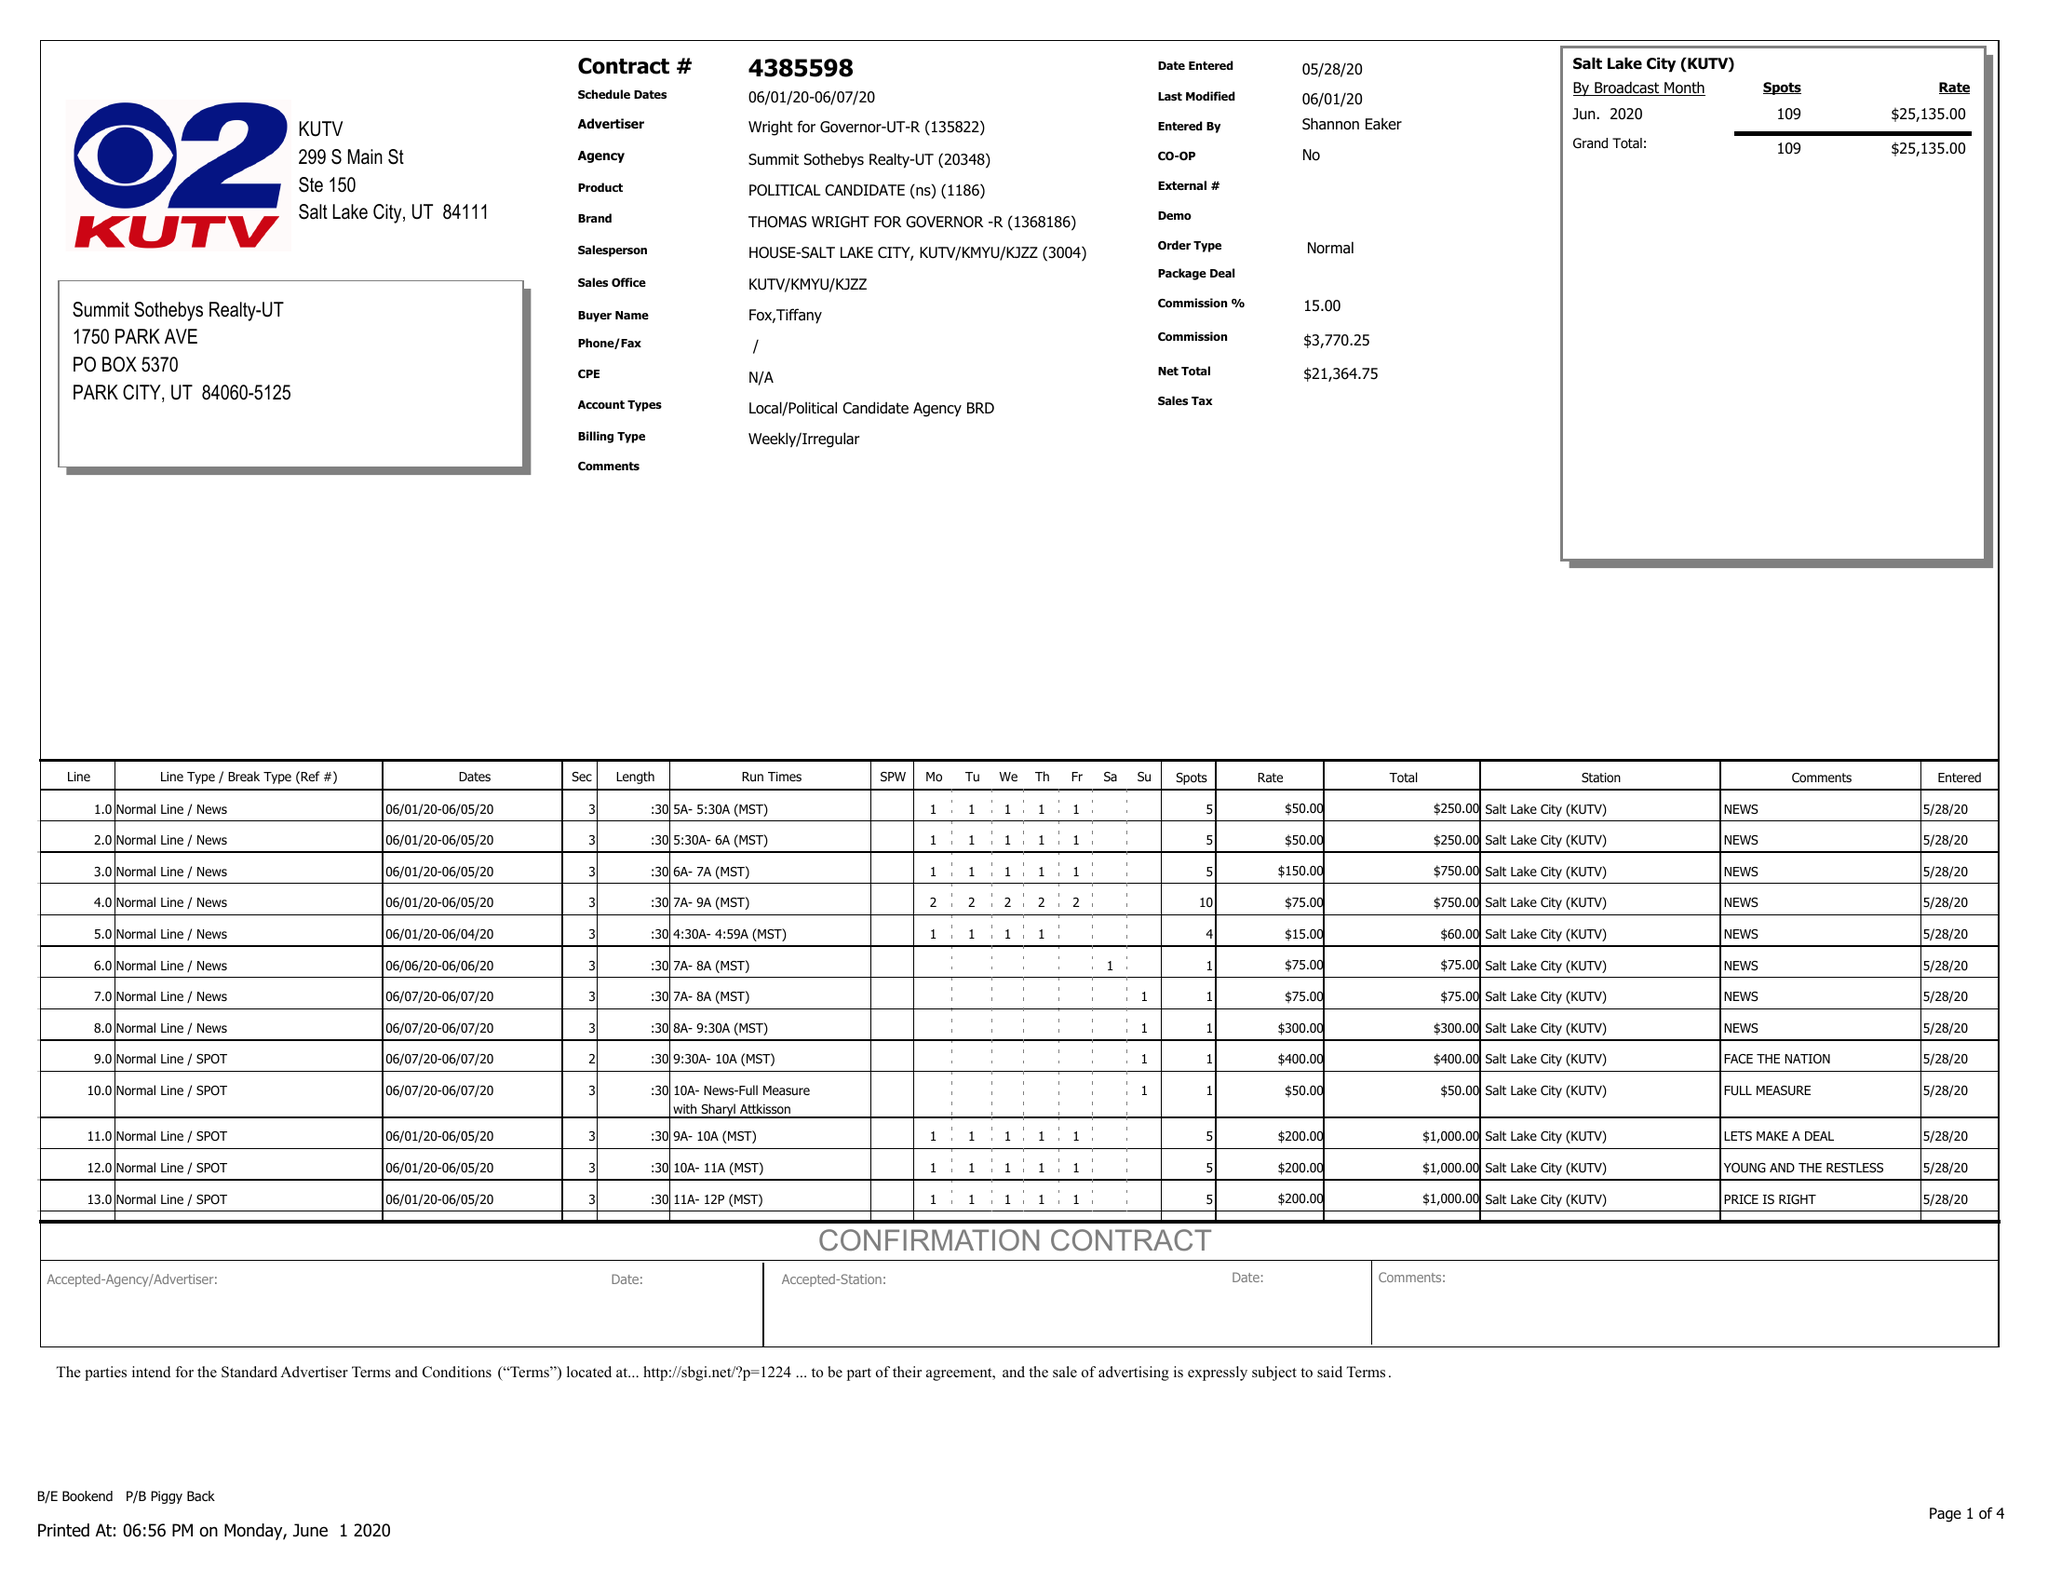What is the value for the flight_to?
Answer the question using a single word or phrase. 06/07/20 